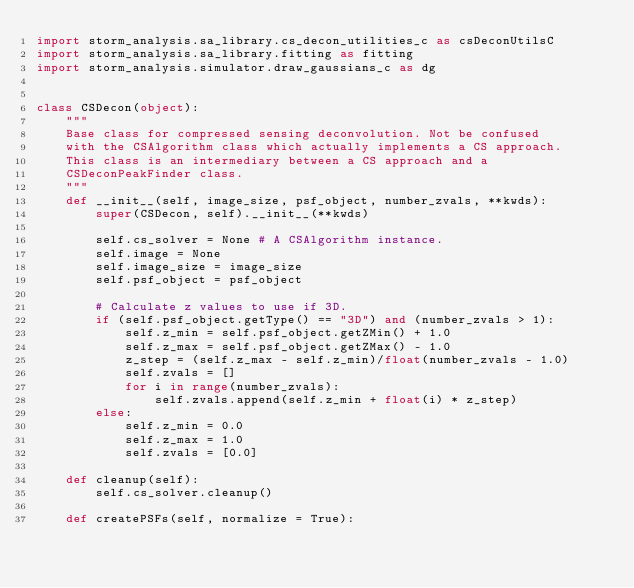<code> <loc_0><loc_0><loc_500><loc_500><_Python_>import storm_analysis.sa_library.cs_decon_utilities_c as csDeconUtilsC
import storm_analysis.sa_library.fitting as fitting
import storm_analysis.simulator.draw_gaussians_c as dg


class CSDecon(object):
    """
    Base class for compressed sensing deconvolution. Not be confused
    with the CSAlgorithm class which actually implements a CS approach.
    This class is an intermediary between a CS approach and a 
    CSDeconPeakFinder class.
    """
    def __init__(self, image_size, psf_object, number_zvals, **kwds):
        super(CSDecon, self).__init__(**kwds)
        
        self.cs_solver = None # A CSAlgorithm instance.
        self.image = None
        self.image_size = image_size
        self.psf_object = psf_object

        # Calculate z values to use if 3D.
        if (self.psf_object.getType() == "3D") and (number_zvals > 1):
            self.z_min = self.psf_object.getZMin() + 1.0
            self.z_max = self.psf_object.getZMax() - 1.0
            z_step = (self.z_max - self.z_min)/float(number_zvals - 1.0)        
            self.zvals = []
            for i in range(number_zvals):
                self.zvals.append(self.z_min + float(i) * z_step)
        else:
            self.z_min = 0.0
            self.z_max = 1.0
            self.zvals = [0.0]

    def cleanup(self):
        self.cs_solver.cleanup()

    def createPSFs(self, normalize = True):</code> 